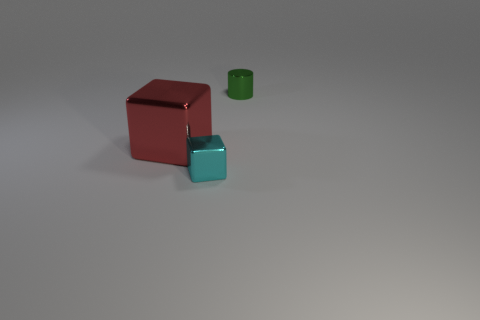Add 1 tiny cyan things. How many objects exist? 4 Subtract all cylinders. How many objects are left? 2 Subtract all tiny shiny cylinders. Subtract all red metal cubes. How many objects are left? 1 Add 1 cylinders. How many cylinders are left? 2 Add 3 big metallic cylinders. How many big metallic cylinders exist? 3 Subtract 0 green balls. How many objects are left? 3 